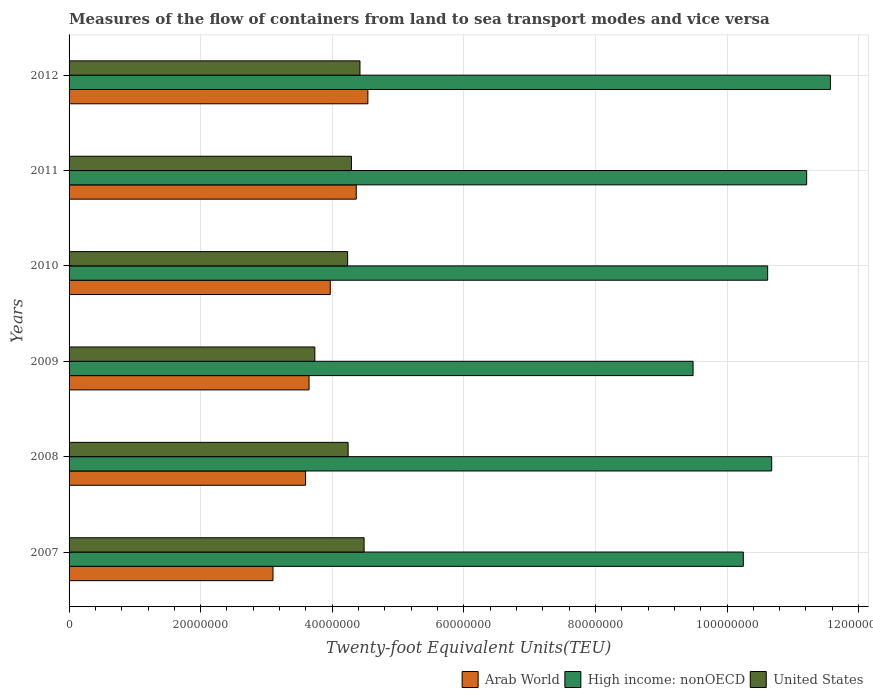How many different coloured bars are there?
Offer a terse response. 3. Are the number of bars on each tick of the Y-axis equal?
Provide a succinct answer. Yes. What is the label of the 1st group of bars from the top?
Give a very brief answer. 2012. What is the container port traffic in High income: nonOECD in 2007?
Keep it short and to the point. 1.02e+08. Across all years, what is the maximum container port traffic in United States?
Provide a succinct answer. 4.48e+07. Across all years, what is the minimum container port traffic in High income: nonOECD?
Provide a short and direct response. 9.48e+07. In which year was the container port traffic in United States maximum?
Make the answer very short. 2007. In which year was the container port traffic in Arab World minimum?
Offer a very short reply. 2007. What is the total container port traffic in United States in the graph?
Offer a terse response. 2.54e+08. What is the difference between the container port traffic in Arab World in 2009 and that in 2012?
Provide a short and direct response. -8.94e+06. What is the difference between the container port traffic in United States in 2010 and the container port traffic in High income: nonOECD in 2008?
Provide a short and direct response. -6.44e+07. What is the average container port traffic in United States per year?
Offer a terse response. 4.23e+07. In the year 2008, what is the difference between the container port traffic in Arab World and container port traffic in United States?
Ensure brevity in your answer.  -6.47e+06. What is the ratio of the container port traffic in High income: nonOECD in 2009 to that in 2010?
Provide a short and direct response. 0.89. What is the difference between the highest and the second highest container port traffic in High income: nonOECD?
Keep it short and to the point. 3.61e+06. What is the difference between the highest and the lowest container port traffic in Arab World?
Provide a short and direct response. 1.44e+07. In how many years, is the container port traffic in United States greater than the average container port traffic in United States taken over all years?
Provide a succinct answer. 4. Is the sum of the container port traffic in Arab World in 2007 and 2008 greater than the maximum container port traffic in High income: nonOECD across all years?
Provide a short and direct response. No. What does the 1st bar from the top in 2011 represents?
Your answer should be compact. United States. How many bars are there?
Give a very brief answer. 18. What is the difference between two consecutive major ticks on the X-axis?
Make the answer very short. 2.00e+07. Are the values on the major ticks of X-axis written in scientific E-notation?
Give a very brief answer. No. Does the graph contain any zero values?
Give a very brief answer. No. How many legend labels are there?
Your answer should be very brief. 3. What is the title of the graph?
Give a very brief answer. Measures of the flow of containers from land to sea transport modes and vice versa. Does "Malawi" appear as one of the legend labels in the graph?
Make the answer very short. No. What is the label or title of the X-axis?
Your answer should be compact. Twenty-foot Equivalent Units(TEU). What is the label or title of the Y-axis?
Keep it short and to the point. Years. What is the Twenty-foot Equivalent Units(TEU) of Arab World in 2007?
Your response must be concise. 3.10e+07. What is the Twenty-foot Equivalent Units(TEU) of High income: nonOECD in 2007?
Your answer should be compact. 1.02e+08. What is the Twenty-foot Equivalent Units(TEU) in United States in 2007?
Keep it short and to the point. 4.48e+07. What is the Twenty-foot Equivalent Units(TEU) of Arab World in 2008?
Offer a very short reply. 3.59e+07. What is the Twenty-foot Equivalent Units(TEU) of High income: nonOECD in 2008?
Provide a succinct answer. 1.07e+08. What is the Twenty-foot Equivalent Units(TEU) of United States in 2008?
Your answer should be very brief. 4.24e+07. What is the Twenty-foot Equivalent Units(TEU) of Arab World in 2009?
Provide a short and direct response. 3.65e+07. What is the Twenty-foot Equivalent Units(TEU) in High income: nonOECD in 2009?
Your answer should be very brief. 9.48e+07. What is the Twenty-foot Equivalent Units(TEU) of United States in 2009?
Provide a short and direct response. 3.74e+07. What is the Twenty-foot Equivalent Units(TEU) in Arab World in 2010?
Provide a short and direct response. 3.97e+07. What is the Twenty-foot Equivalent Units(TEU) of High income: nonOECD in 2010?
Provide a succinct answer. 1.06e+08. What is the Twenty-foot Equivalent Units(TEU) in United States in 2010?
Your answer should be very brief. 4.23e+07. What is the Twenty-foot Equivalent Units(TEU) in Arab World in 2011?
Make the answer very short. 4.36e+07. What is the Twenty-foot Equivalent Units(TEU) in High income: nonOECD in 2011?
Your answer should be compact. 1.12e+08. What is the Twenty-foot Equivalent Units(TEU) in United States in 2011?
Provide a succinct answer. 4.29e+07. What is the Twenty-foot Equivalent Units(TEU) in Arab World in 2012?
Your answer should be compact. 4.54e+07. What is the Twenty-foot Equivalent Units(TEU) of High income: nonOECD in 2012?
Keep it short and to the point. 1.16e+08. What is the Twenty-foot Equivalent Units(TEU) of United States in 2012?
Ensure brevity in your answer.  4.42e+07. Across all years, what is the maximum Twenty-foot Equivalent Units(TEU) in Arab World?
Make the answer very short. 4.54e+07. Across all years, what is the maximum Twenty-foot Equivalent Units(TEU) in High income: nonOECD?
Your answer should be very brief. 1.16e+08. Across all years, what is the maximum Twenty-foot Equivalent Units(TEU) in United States?
Offer a terse response. 4.48e+07. Across all years, what is the minimum Twenty-foot Equivalent Units(TEU) of Arab World?
Make the answer very short. 3.10e+07. Across all years, what is the minimum Twenty-foot Equivalent Units(TEU) in High income: nonOECD?
Give a very brief answer. 9.48e+07. Across all years, what is the minimum Twenty-foot Equivalent Units(TEU) of United States?
Give a very brief answer. 3.74e+07. What is the total Twenty-foot Equivalent Units(TEU) in Arab World in the graph?
Give a very brief answer. 2.32e+08. What is the total Twenty-foot Equivalent Units(TEU) of High income: nonOECD in the graph?
Give a very brief answer. 6.38e+08. What is the total Twenty-foot Equivalent Units(TEU) in United States in the graph?
Give a very brief answer. 2.54e+08. What is the difference between the Twenty-foot Equivalent Units(TEU) in Arab World in 2007 and that in 2008?
Offer a terse response. -4.95e+06. What is the difference between the Twenty-foot Equivalent Units(TEU) of High income: nonOECD in 2007 and that in 2008?
Your answer should be compact. -4.31e+06. What is the difference between the Twenty-foot Equivalent Units(TEU) of United States in 2007 and that in 2008?
Offer a terse response. 2.43e+06. What is the difference between the Twenty-foot Equivalent Units(TEU) of Arab World in 2007 and that in 2009?
Keep it short and to the point. -5.48e+06. What is the difference between the Twenty-foot Equivalent Units(TEU) in High income: nonOECD in 2007 and that in 2009?
Give a very brief answer. 7.63e+06. What is the difference between the Twenty-foot Equivalent Units(TEU) in United States in 2007 and that in 2009?
Ensure brevity in your answer.  7.49e+06. What is the difference between the Twenty-foot Equivalent Units(TEU) in Arab World in 2007 and that in 2010?
Give a very brief answer. -8.71e+06. What is the difference between the Twenty-foot Equivalent Units(TEU) in High income: nonOECD in 2007 and that in 2010?
Your answer should be compact. -3.70e+06. What is the difference between the Twenty-foot Equivalent Units(TEU) of United States in 2007 and that in 2010?
Your answer should be compact. 2.50e+06. What is the difference between the Twenty-foot Equivalent Units(TEU) in Arab World in 2007 and that in 2011?
Your answer should be very brief. -1.27e+07. What is the difference between the Twenty-foot Equivalent Units(TEU) of High income: nonOECD in 2007 and that in 2011?
Offer a terse response. -9.63e+06. What is the difference between the Twenty-foot Equivalent Units(TEU) of United States in 2007 and that in 2011?
Give a very brief answer. 1.92e+06. What is the difference between the Twenty-foot Equivalent Units(TEU) in Arab World in 2007 and that in 2012?
Your response must be concise. -1.44e+07. What is the difference between the Twenty-foot Equivalent Units(TEU) of High income: nonOECD in 2007 and that in 2012?
Give a very brief answer. -1.32e+07. What is the difference between the Twenty-foot Equivalent Units(TEU) of United States in 2007 and that in 2012?
Provide a short and direct response. 6.28e+05. What is the difference between the Twenty-foot Equivalent Units(TEU) in Arab World in 2008 and that in 2009?
Give a very brief answer. -5.29e+05. What is the difference between the Twenty-foot Equivalent Units(TEU) of High income: nonOECD in 2008 and that in 2009?
Provide a short and direct response. 1.19e+07. What is the difference between the Twenty-foot Equivalent Units(TEU) in United States in 2008 and that in 2009?
Your answer should be very brief. 5.06e+06. What is the difference between the Twenty-foot Equivalent Units(TEU) in Arab World in 2008 and that in 2010?
Your answer should be very brief. -3.75e+06. What is the difference between the Twenty-foot Equivalent Units(TEU) of High income: nonOECD in 2008 and that in 2010?
Provide a short and direct response. 6.11e+05. What is the difference between the Twenty-foot Equivalent Units(TEU) in United States in 2008 and that in 2010?
Provide a short and direct response. 7.43e+04. What is the difference between the Twenty-foot Equivalent Units(TEU) of Arab World in 2008 and that in 2011?
Your answer should be very brief. -7.70e+06. What is the difference between the Twenty-foot Equivalent Units(TEU) in High income: nonOECD in 2008 and that in 2011?
Keep it short and to the point. -5.32e+06. What is the difference between the Twenty-foot Equivalent Units(TEU) in United States in 2008 and that in 2011?
Make the answer very short. -5.04e+05. What is the difference between the Twenty-foot Equivalent Units(TEU) of Arab World in 2008 and that in 2012?
Offer a very short reply. -9.47e+06. What is the difference between the Twenty-foot Equivalent Units(TEU) of High income: nonOECD in 2008 and that in 2012?
Your answer should be very brief. -8.93e+06. What is the difference between the Twenty-foot Equivalent Units(TEU) of United States in 2008 and that in 2012?
Make the answer very short. -1.80e+06. What is the difference between the Twenty-foot Equivalent Units(TEU) of Arab World in 2009 and that in 2010?
Provide a succinct answer. -3.22e+06. What is the difference between the Twenty-foot Equivalent Units(TEU) in High income: nonOECD in 2009 and that in 2010?
Offer a very short reply. -1.13e+07. What is the difference between the Twenty-foot Equivalent Units(TEU) in United States in 2009 and that in 2010?
Your answer should be compact. -4.98e+06. What is the difference between the Twenty-foot Equivalent Units(TEU) in Arab World in 2009 and that in 2011?
Provide a short and direct response. -7.17e+06. What is the difference between the Twenty-foot Equivalent Units(TEU) in High income: nonOECD in 2009 and that in 2011?
Provide a succinct answer. -1.73e+07. What is the difference between the Twenty-foot Equivalent Units(TEU) in United States in 2009 and that in 2011?
Give a very brief answer. -5.56e+06. What is the difference between the Twenty-foot Equivalent Units(TEU) of Arab World in 2009 and that in 2012?
Provide a short and direct response. -8.94e+06. What is the difference between the Twenty-foot Equivalent Units(TEU) in High income: nonOECD in 2009 and that in 2012?
Your answer should be very brief. -2.09e+07. What is the difference between the Twenty-foot Equivalent Units(TEU) of United States in 2009 and that in 2012?
Your answer should be very brief. -6.86e+06. What is the difference between the Twenty-foot Equivalent Units(TEU) of Arab World in 2010 and that in 2011?
Offer a very short reply. -3.95e+06. What is the difference between the Twenty-foot Equivalent Units(TEU) in High income: nonOECD in 2010 and that in 2011?
Provide a short and direct response. -5.93e+06. What is the difference between the Twenty-foot Equivalent Units(TEU) in United States in 2010 and that in 2011?
Your answer should be very brief. -5.78e+05. What is the difference between the Twenty-foot Equivalent Units(TEU) in Arab World in 2010 and that in 2012?
Your answer should be very brief. -5.71e+06. What is the difference between the Twenty-foot Equivalent Units(TEU) in High income: nonOECD in 2010 and that in 2012?
Keep it short and to the point. -9.54e+06. What is the difference between the Twenty-foot Equivalent Units(TEU) in United States in 2010 and that in 2012?
Provide a short and direct response. -1.87e+06. What is the difference between the Twenty-foot Equivalent Units(TEU) in Arab World in 2011 and that in 2012?
Provide a short and direct response. -1.76e+06. What is the difference between the Twenty-foot Equivalent Units(TEU) of High income: nonOECD in 2011 and that in 2012?
Your answer should be very brief. -3.61e+06. What is the difference between the Twenty-foot Equivalent Units(TEU) of United States in 2011 and that in 2012?
Your response must be concise. -1.30e+06. What is the difference between the Twenty-foot Equivalent Units(TEU) in Arab World in 2007 and the Twenty-foot Equivalent Units(TEU) in High income: nonOECD in 2008?
Provide a succinct answer. -7.58e+07. What is the difference between the Twenty-foot Equivalent Units(TEU) of Arab World in 2007 and the Twenty-foot Equivalent Units(TEU) of United States in 2008?
Your answer should be compact. -1.14e+07. What is the difference between the Twenty-foot Equivalent Units(TEU) of High income: nonOECD in 2007 and the Twenty-foot Equivalent Units(TEU) of United States in 2008?
Provide a succinct answer. 6.01e+07. What is the difference between the Twenty-foot Equivalent Units(TEU) in Arab World in 2007 and the Twenty-foot Equivalent Units(TEU) in High income: nonOECD in 2009?
Keep it short and to the point. -6.38e+07. What is the difference between the Twenty-foot Equivalent Units(TEU) of Arab World in 2007 and the Twenty-foot Equivalent Units(TEU) of United States in 2009?
Your answer should be compact. -6.36e+06. What is the difference between the Twenty-foot Equivalent Units(TEU) of High income: nonOECD in 2007 and the Twenty-foot Equivalent Units(TEU) of United States in 2009?
Offer a very short reply. 6.51e+07. What is the difference between the Twenty-foot Equivalent Units(TEU) of Arab World in 2007 and the Twenty-foot Equivalent Units(TEU) of High income: nonOECD in 2010?
Your answer should be compact. -7.52e+07. What is the difference between the Twenty-foot Equivalent Units(TEU) in Arab World in 2007 and the Twenty-foot Equivalent Units(TEU) in United States in 2010?
Your answer should be compact. -1.13e+07. What is the difference between the Twenty-foot Equivalent Units(TEU) in High income: nonOECD in 2007 and the Twenty-foot Equivalent Units(TEU) in United States in 2010?
Provide a succinct answer. 6.01e+07. What is the difference between the Twenty-foot Equivalent Units(TEU) of Arab World in 2007 and the Twenty-foot Equivalent Units(TEU) of High income: nonOECD in 2011?
Provide a succinct answer. -8.11e+07. What is the difference between the Twenty-foot Equivalent Units(TEU) in Arab World in 2007 and the Twenty-foot Equivalent Units(TEU) in United States in 2011?
Provide a succinct answer. -1.19e+07. What is the difference between the Twenty-foot Equivalent Units(TEU) in High income: nonOECD in 2007 and the Twenty-foot Equivalent Units(TEU) in United States in 2011?
Ensure brevity in your answer.  5.96e+07. What is the difference between the Twenty-foot Equivalent Units(TEU) of Arab World in 2007 and the Twenty-foot Equivalent Units(TEU) of High income: nonOECD in 2012?
Your response must be concise. -8.47e+07. What is the difference between the Twenty-foot Equivalent Units(TEU) in Arab World in 2007 and the Twenty-foot Equivalent Units(TEU) in United States in 2012?
Make the answer very short. -1.32e+07. What is the difference between the Twenty-foot Equivalent Units(TEU) of High income: nonOECD in 2007 and the Twenty-foot Equivalent Units(TEU) of United States in 2012?
Provide a succinct answer. 5.83e+07. What is the difference between the Twenty-foot Equivalent Units(TEU) of Arab World in 2008 and the Twenty-foot Equivalent Units(TEU) of High income: nonOECD in 2009?
Make the answer very short. -5.89e+07. What is the difference between the Twenty-foot Equivalent Units(TEU) of Arab World in 2008 and the Twenty-foot Equivalent Units(TEU) of United States in 2009?
Your answer should be compact. -1.41e+06. What is the difference between the Twenty-foot Equivalent Units(TEU) in High income: nonOECD in 2008 and the Twenty-foot Equivalent Units(TEU) in United States in 2009?
Offer a very short reply. 6.94e+07. What is the difference between the Twenty-foot Equivalent Units(TEU) in Arab World in 2008 and the Twenty-foot Equivalent Units(TEU) in High income: nonOECD in 2010?
Give a very brief answer. -7.02e+07. What is the difference between the Twenty-foot Equivalent Units(TEU) of Arab World in 2008 and the Twenty-foot Equivalent Units(TEU) of United States in 2010?
Offer a very short reply. -6.39e+06. What is the difference between the Twenty-foot Equivalent Units(TEU) of High income: nonOECD in 2008 and the Twenty-foot Equivalent Units(TEU) of United States in 2010?
Keep it short and to the point. 6.44e+07. What is the difference between the Twenty-foot Equivalent Units(TEU) in Arab World in 2008 and the Twenty-foot Equivalent Units(TEU) in High income: nonOECD in 2011?
Offer a very short reply. -7.62e+07. What is the difference between the Twenty-foot Equivalent Units(TEU) of Arab World in 2008 and the Twenty-foot Equivalent Units(TEU) of United States in 2011?
Offer a terse response. -6.97e+06. What is the difference between the Twenty-foot Equivalent Units(TEU) in High income: nonOECD in 2008 and the Twenty-foot Equivalent Units(TEU) in United States in 2011?
Give a very brief answer. 6.39e+07. What is the difference between the Twenty-foot Equivalent Units(TEU) of Arab World in 2008 and the Twenty-foot Equivalent Units(TEU) of High income: nonOECD in 2012?
Ensure brevity in your answer.  -7.98e+07. What is the difference between the Twenty-foot Equivalent Units(TEU) of Arab World in 2008 and the Twenty-foot Equivalent Units(TEU) of United States in 2012?
Keep it short and to the point. -8.27e+06. What is the difference between the Twenty-foot Equivalent Units(TEU) in High income: nonOECD in 2008 and the Twenty-foot Equivalent Units(TEU) in United States in 2012?
Your answer should be compact. 6.26e+07. What is the difference between the Twenty-foot Equivalent Units(TEU) of Arab World in 2009 and the Twenty-foot Equivalent Units(TEU) of High income: nonOECD in 2010?
Ensure brevity in your answer.  -6.97e+07. What is the difference between the Twenty-foot Equivalent Units(TEU) in Arab World in 2009 and the Twenty-foot Equivalent Units(TEU) in United States in 2010?
Provide a short and direct response. -5.86e+06. What is the difference between the Twenty-foot Equivalent Units(TEU) in High income: nonOECD in 2009 and the Twenty-foot Equivalent Units(TEU) in United States in 2010?
Keep it short and to the point. 5.25e+07. What is the difference between the Twenty-foot Equivalent Units(TEU) in Arab World in 2009 and the Twenty-foot Equivalent Units(TEU) in High income: nonOECD in 2011?
Your answer should be compact. -7.56e+07. What is the difference between the Twenty-foot Equivalent Units(TEU) in Arab World in 2009 and the Twenty-foot Equivalent Units(TEU) in United States in 2011?
Your response must be concise. -6.44e+06. What is the difference between the Twenty-foot Equivalent Units(TEU) of High income: nonOECD in 2009 and the Twenty-foot Equivalent Units(TEU) of United States in 2011?
Give a very brief answer. 5.19e+07. What is the difference between the Twenty-foot Equivalent Units(TEU) of Arab World in 2009 and the Twenty-foot Equivalent Units(TEU) of High income: nonOECD in 2012?
Offer a terse response. -7.92e+07. What is the difference between the Twenty-foot Equivalent Units(TEU) of Arab World in 2009 and the Twenty-foot Equivalent Units(TEU) of United States in 2012?
Offer a terse response. -7.74e+06. What is the difference between the Twenty-foot Equivalent Units(TEU) in High income: nonOECD in 2009 and the Twenty-foot Equivalent Units(TEU) in United States in 2012?
Your response must be concise. 5.06e+07. What is the difference between the Twenty-foot Equivalent Units(TEU) of Arab World in 2010 and the Twenty-foot Equivalent Units(TEU) of High income: nonOECD in 2011?
Make the answer very short. -7.24e+07. What is the difference between the Twenty-foot Equivalent Units(TEU) of Arab World in 2010 and the Twenty-foot Equivalent Units(TEU) of United States in 2011?
Ensure brevity in your answer.  -3.22e+06. What is the difference between the Twenty-foot Equivalent Units(TEU) of High income: nonOECD in 2010 and the Twenty-foot Equivalent Units(TEU) of United States in 2011?
Provide a succinct answer. 6.33e+07. What is the difference between the Twenty-foot Equivalent Units(TEU) in Arab World in 2010 and the Twenty-foot Equivalent Units(TEU) in High income: nonOECD in 2012?
Give a very brief answer. -7.60e+07. What is the difference between the Twenty-foot Equivalent Units(TEU) in Arab World in 2010 and the Twenty-foot Equivalent Units(TEU) in United States in 2012?
Offer a very short reply. -4.51e+06. What is the difference between the Twenty-foot Equivalent Units(TEU) of High income: nonOECD in 2010 and the Twenty-foot Equivalent Units(TEU) of United States in 2012?
Keep it short and to the point. 6.20e+07. What is the difference between the Twenty-foot Equivalent Units(TEU) in Arab World in 2011 and the Twenty-foot Equivalent Units(TEU) in High income: nonOECD in 2012?
Provide a short and direct response. -7.21e+07. What is the difference between the Twenty-foot Equivalent Units(TEU) in Arab World in 2011 and the Twenty-foot Equivalent Units(TEU) in United States in 2012?
Ensure brevity in your answer.  -5.62e+05. What is the difference between the Twenty-foot Equivalent Units(TEU) of High income: nonOECD in 2011 and the Twenty-foot Equivalent Units(TEU) of United States in 2012?
Offer a very short reply. 6.79e+07. What is the average Twenty-foot Equivalent Units(TEU) of Arab World per year?
Offer a terse response. 3.87e+07. What is the average Twenty-foot Equivalent Units(TEU) of High income: nonOECD per year?
Make the answer very short. 1.06e+08. What is the average Twenty-foot Equivalent Units(TEU) in United States per year?
Your response must be concise. 4.23e+07. In the year 2007, what is the difference between the Twenty-foot Equivalent Units(TEU) of Arab World and Twenty-foot Equivalent Units(TEU) of High income: nonOECD?
Your response must be concise. -7.15e+07. In the year 2007, what is the difference between the Twenty-foot Equivalent Units(TEU) in Arab World and Twenty-foot Equivalent Units(TEU) in United States?
Provide a succinct answer. -1.38e+07. In the year 2007, what is the difference between the Twenty-foot Equivalent Units(TEU) in High income: nonOECD and Twenty-foot Equivalent Units(TEU) in United States?
Provide a succinct answer. 5.76e+07. In the year 2008, what is the difference between the Twenty-foot Equivalent Units(TEU) in Arab World and Twenty-foot Equivalent Units(TEU) in High income: nonOECD?
Offer a very short reply. -7.08e+07. In the year 2008, what is the difference between the Twenty-foot Equivalent Units(TEU) of Arab World and Twenty-foot Equivalent Units(TEU) of United States?
Keep it short and to the point. -6.47e+06. In the year 2008, what is the difference between the Twenty-foot Equivalent Units(TEU) of High income: nonOECD and Twenty-foot Equivalent Units(TEU) of United States?
Provide a succinct answer. 6.44e+07. In the year 2009, what is the difference between the Twenty-foot Equivalent Units(TEU) of Arab World and Twenty-foot Equivalent Units(TEU) of High income: nonOECD?
Keep it short and to the point. -5.84e+07. In the year 2009, what is the difference between the Twenty-foot Equivalent Units(TEU) in Arab World and Twenty-foot Equivalent Units(TEU) in United States?
Your answer should be compact. -8.78e+05. In the year 2009, what is the difference between the Twenty-foot Equivalent Units(TEU) of High income: nonOECD and Twenty-foot Equivalent Units(TEU) of United States?
Keep it short and to the point. 5.75e+07. In the year 2010, what is the difference between the Twenty-foot Equivalent Units(TEU) of Arab World and Twenty-foot Equivalent Units(TEU) of High income: nonOECD?
Offer a terse response. -6.65e+07. In the year 2010, what is the difference between the Twenty-foot Equivalent Units(TEU) in Arab World and Twenty-foot Equivalent Units(TEU) in United States?
Make the answer very short. -2.64e+06. In the year 2010, what is the difference between the Twenty-foot Equivalent Units(TEU) of High income: nonOECD and Twenty-foot Equivalent Units(TEU) of United States?
Give a very brief answer. 6.38e+07. In the year 2011, what is the difference between the Twenty-foot Equivalent Units(TEU) in Arab World and Twenty-foot Equivalent Units(TEU) in High income: nonOECD?
Provide a short and direct response. -6.85e+07. In the year 2011, what is the difference between the Twenty-foot Equivalent Units(TEU) of Arab World and Twenty-foot Equivalent Units(TEU) of United States?
Ensure brevity in your answer.  7.34e+05. In the year 2011, what is the difference between the Twenty-foot Equivalent Units(TEU) in High income: nonOECD and Twenty-foot Equivalent Units(TEU) in United States?
Make the answer very short. 6.92e+07. In the year 2012, what is the difference between the Twenty-foot Equivalent Units(TEU) of Arab World and Twenty-foot Equivalent Units(TEU) of High income: nonOECD?
Provide a succinct answer. -7.03e+07. In the year 2012, what is the difference between the Twenty-foot Equivalent Units(TEU) in Arab World and Twenty-foot Equivalent Units(TEU) in United States?
Offer a terse response. 1.20e+06. In the year 2012, what is the difference between the Twenty-foot Equivalent Units(TEU) in High income: nonOECD and Twenty-foot Equivalent Units(TEU) in United States?
Keep it short and to the point. 7.15e+07. What is the ratio of the Twenty-foot Equivalent Units(TEU) in Arab World in 2007 to that in 2008?
Offer a terse response. 0.86. What is the ratio of the Twenty-foot Equivalent Units(TEU) in High income: nonOECD in 2007 to that in 2008?
Offer a very short reply. 0.96. What is the ratio of the Twenty-foot Equivalent Units(TEU) in United States in 2007 to that in 2008?
Your answer should be very brief. 1.06. What is the ratio of the Twenty-foot Equivalent Units(TEU) in Arab World in 2007 to that in 2009?
Provide a short and direct response. 0.85. What is the ratio of the Twenty-foot Equivalent Units(TEU) of High income: nonOECD in 2007 to that in 2009?
Keep it short and to the point. 1.08. What is the ratio of the Twenty-foot Equivalent Units(TEU) in United States in 2007 to that in 2009?
Your response must be concise. 1.2. What is the ratio of the Twenty-foot Equivalent Units(TEU) of Arab World in 2007 to that in 2010?
Your response must be concise. 0.78. What is the ratio of the Twenty-foot Equivalent Units(TEU) in High income: nonOECD in 2007 to that in 2010?
Offer a terse response. 0.97. What is the ratio of the Twenty-foot Equivalent Units(TEU) of United States in 2007 to that in 2010?
Provide a succinct answer. 1.06. What is the ratio of the Twenty-foot Equivalent Units(TEU) in Arab World in 2007 to that in 2011?
Provide a short and direct response. 0.71. What is the ratio of the Twenty-foot Equivalent Units(TEU) in High income: nonOECD in 2007 to that in 2011?
Give a very brief answer. 0.91. What is the ratio of the Twenty-foot Equivalent Units(TEU) in United States in 2007 to that in 2011?
Make the answer very short. 1.04. What is the ratio of the Twenty-foot Equivalent Units(TEU) in Arab World in 2007 to that in 2012?
Your answer should be very brief. 0.68. What is the ratio of the Twenty-foot Equivalent Units(TEU) of High income: nonOECD in 2007 to that in 2012?
Keep it short and to the point. 0.89. What is the ratio of the Twenty-foot Equivalent Units(TEU) of United States in 2007 to that in 2012?
Your answer should be compact. 1.01. What is the ratio of the Twenty-foot Equivalent Units(TEU) of Arab World in 2008 to that in 2009?
Offer a terse response. 0.99. What is the ratio of the Twenty-foot Equivalent Units(TEU) of High income: nonOECD in 2008 to that in 2009?
Your answer should be very brief. 1.13. What is the ratio of the Twenty-foot Equivalent Units(TEU) in United States in 2008 to that in 2009?
Your answer should be compact. 1.14. What is the ratio of the Twenty-foot Equivalent Units(TEU) of Arab World in 2008 to that in 2010?
Your answer should be very brief. 0.91. What is the ratio of the Twenty-foot Equivalent Units(TEU) of Arab World in 2008 to that in 2011?
Ensure brevity in your answer.  0.82. What is the ratio of the Twenty-foot Equivalent Units(TEU) of High income: nonOECD in 2008 to that in 2011?
Provide a succinct answer. 0.95. What is the ratio of the Twenty-foot Equivalent Units(TEU) of United States in 2008 to that in 2011?
Your answer should be very brief. 0.99. What is the ratio of the Twenty-foot Equivalent Units(TEU) of Arab World in 2008 to that in 2012?
Make the answer very short. 0.79. What is the ratio of the Twenty-foot Equivalent Units(TEU) of High income: nonOECD in 2008 to that in 2012?
Make the answer very short. 0.92. What is the ratio of the Twenty-foot Equivalent Units(TEU) in United States in 2008 to that in 2012?
Provide a succinct answer. 0.96. What is the ratio of the Twenty-foot Equivalent Units(TEU) in Arab World in 2009 to that in 2010?
Your response must be concise. 0.92. What is the ratio of the Twenty-foot Equivalent Units(TEU) of High income: nonOECD in 2009 to that in 2010?
Your response must be concise. 0.89. What is the ratio of the Twenty-foot Equivalent Units(TEU) in United States in 2009 to that in 2010?
Your response must be concise. 0.88. What is the ratio of the Twenty-foot Equivalent Units(TEU) of Arab World in 2009 to that in 2011?
Give a very brief answer. 0.84. What is the ratio of the Twenty-foot Equivalent Units(TEU) of High income: nonOECD in 2009 to that in 2011?
Offer a terse response. 0.85. What is the ratio of the Twenty-foot Equivalent Units(TEU) in United States in 2009 to that in 2011?
Provide a short and direct response. 0.87. What is the ratio of the Twenty-foot Equivalent Units(TEU) of Arab World in 2009 to that in 2012?
Ensure brevity in your answer.  0.8. What is the ratio of the Twenty-foot Equivalent Units(TEU) in High income: nonOECD in 2009 to that in 2012?
Keep it short and to the point. 0.82. What is the ratio of the Twenty-foot Equivalent Units(TEU) in United States in 2009 to that in 2012?
Your answer should be very brief. 0.84. What is the ratio of the Twenty-foot Equivalent Units(TEU) in Arab World in 2010 to that in 2011?
Make the answer very short. 0.91. What is the ratio of the Twenty-foot Equivalent Units(TEU) in High income: nonOECD in 2010 to that in 2011?
Ensure brevity in your answer.  0.95. What is the ratio of the Twenty-foot Equivalent Units(TEU) of United States in 2010 to that in 2011?
Your answer should be very brief. 0.99. What is the ratio of the Twenty-foot Equivalent Units(TEU) in Arab World in 2010 to that in 2012?
Offer a very short reply. 0.87. What is the ratio of the Twenty-foot Equivalent Units(TEU) of High income: nonOECD in 2010 to that in 2012?
Make the answer very short. 0.92. What is the ratio of the Twenty-foot Equivalent Units(TEU) in United States in 2010 to that in 2012?
Your answer should be compact. 0.96. What is the ratio of the Twenty-foot Equivalent Units(TEU) of Arab World in 2011 to that in 2012?
Keep it short and to the point. 0.96. What is the ratio of the Twenty-foot Equivalent Units(TEU) of High income: nonOECD in 2011 to that in 2012?
Make the answer very short. 0.97. What is the ratio of the Twenty-foot Equivalent Units(TEU) of United States in 2011 to that in 2012?
Give a very brief answer. 0.97. What is the difference between the highest and the second highest Twenty-foot Equivalent Units(TEU) of Arab World?
Give a very brief answer. 1.76e+06. What is the difference between the highest and the second highest Twenty-foot Equivalent Units(TEU) of High income: nonOECD?
Provide a short and direct response. 3.61e+06. What is the difference between the highest and the second highest Twenty-foot Equivalent Units(TEU) in United States?
Your answer should be compact. 6.28e+05. What is the difference between the highest and the lowest Twenty-foot Equivalent Units(TEU) of Arab World?
Provide a succinct answer. 1.44e+07. What is the difference between the highest and the lowest Twenty-foot Equivalent Units(TEU) of High income: nonOECD?
Offer a terse response. 2.09e+07. What is the difference between the highest and the lowest Twenty-foot Equivalent Units(TEU) of United States?
Ensure brevity in your answer.  7.49e+06. 